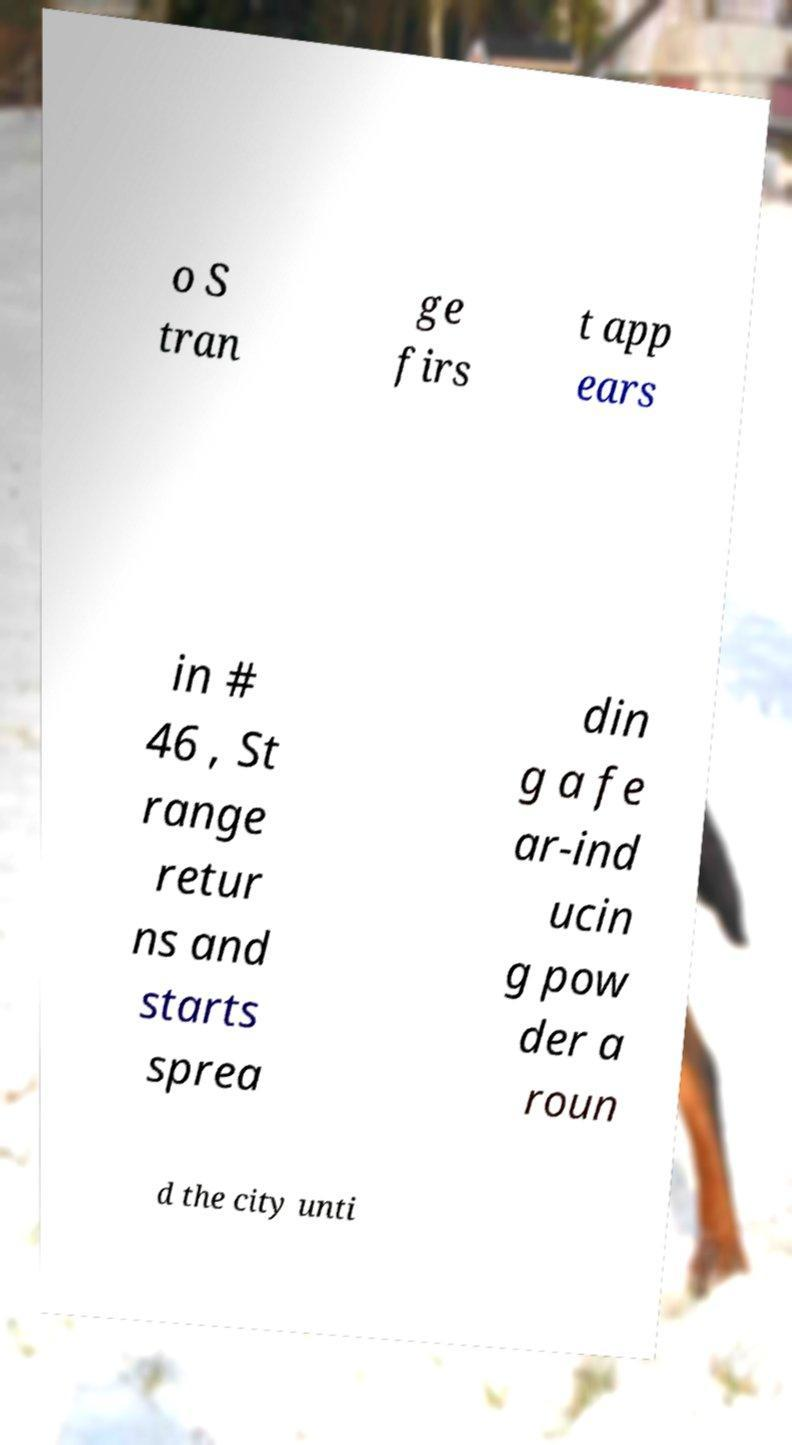There's text embedded in this image that I need extracted. Can you transcribe it verbatim? o S tran ge firs t app ears in # 46 , St range retur ns and starts sprea din g a fe ar-ind ucin g pow der a roun d the city unti 